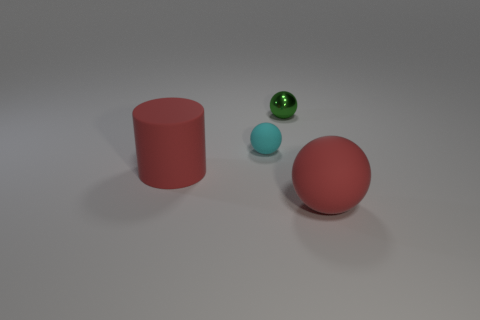There is a rubber sphere that is left of the tiny shiny object; is it the same size as the green metallic object that is behind the tiny cyan matte ball? Upon closer inspection of the image, the red rubber sphere to the left of the tiny shiny object appears to be slightly larger than the green metallic object positioned behind the tiny cyan matte ball. Their sizes are similar, yet not identical, with the red sphere having a marginally greater volume. 